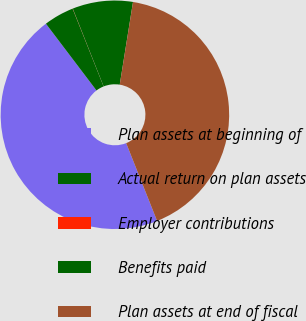<chart> <loc_0><loc_0><loc_500><loc_500><pie_chart><fcel>Plan assets at beginning of<fcel>Actual return on plan assets<fcel>Employer contributions<fcel>Benefits paid<fcel>Plan assets at end of fiscal<nl><fcel>45.7%<fcel>4.28%<fcel>0.03%<fcel>8.54%<fcel>41.44%<nl></chart> 